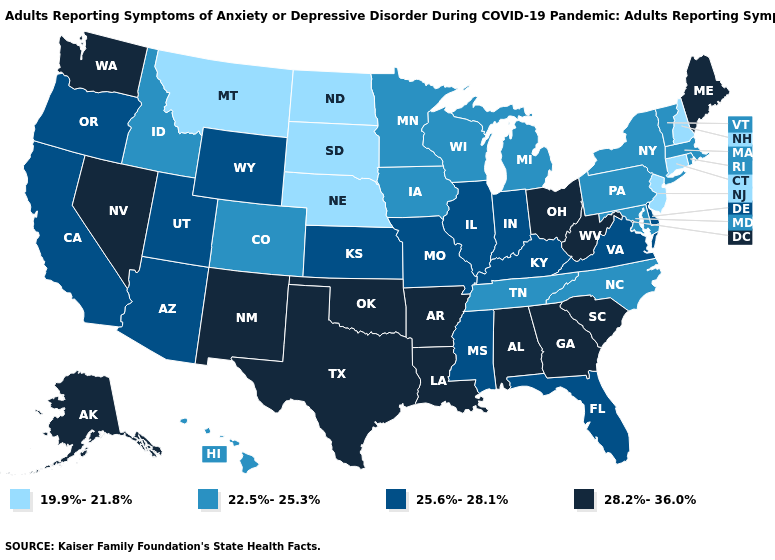What is the value of Nebraska?
Short answer required. 19.9%-21.8%. Which states have the lowest value in the USA?
Write a very short answer. Connecticut, Montana, Nebraska, New Hampshire, New Jersey, North Dakota, South Dakota. Does Montana have the highest value in the USA?
Be succinct. No. What is the highest value in the USA?
Keep it brief. 28.2%-36.0%. Does Alaska have the highest value in the West?
Short answer required. Yes. Name the states that have a value in the range 25.6%-28.1%?
Write a very short answer. Arizona, California, Delaware, Florida, Illinois, Indiana, Kansas, Kentucky, Mississippi, Missouri, Oregon, Utah, Virginia, Wyoming. What is the value of Michigan?
Answer briefly. 22.5%-25.3%. Does Rhode Island have a lower value than Arizona?
Concise answer only. Yes. Does Nevada have a lower value than Tennessee?
Answer briefly. No. Which states have the highest value in the USA?
Keep it brief. Alabama, Alaska, Arkansas, Georgia, Louisiana, Maine, Nevada, New Mexico, Ohio, Oklahoma, South Carolina, Texas, Washington, West Virginia. What is the highest value in states that border Vermont?
Quick response, please. 22.5%-25.3%. What is the lowest value in states that border Louisiana?
Quick response, please. 25.6%-28.1%. Among the states that border Wisconsin , does Iowa have the lowest value?
Keep it brief. Yes. Among the states that border Iowa , which have the highest value?
Concise answer only. Illinois, Missouri. Among the states that border New York , does Pennsylvania have the lowest value?
Short answer required. No. 